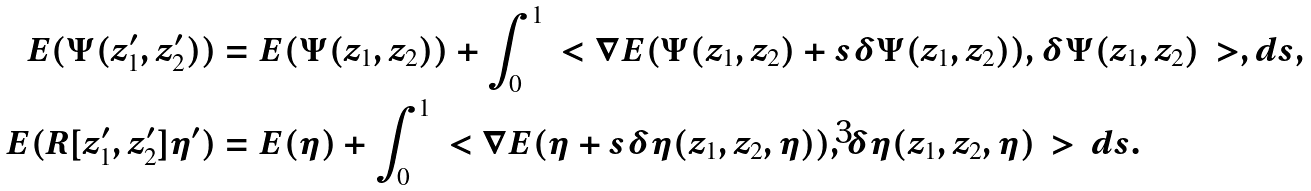<formula> <loc_0><loc_0><loc_500><loc_500>E ( \Psi ( z _ { 1 } ^ { \prime } , z _ { 2 } ^ { \prime } ) ) & = E ( \Psi ( z _ { 1 } , z _ { 2 } ) ) + \int _ { 0 } ^ { 1 } \ < \nabla E ( \Psi ( z _ { 1 } , z _ { 2 } ) + s \delta \Psi ( z _ { 1 } , z _ { 2 } ) ) , \delta \Psi ( z _ { 1 } , z _ { 2 } ) \ > , d s , \\ E ( R [ z _ { 1 } ^ { \prime } , z _ { 2 } ^ { \prime } ] \eta ^ { \prime } ) & = E ( \eta ) + \int _ { 0 } ^ { 1 } \ < \nabla E ( \eta + s \delta \eta ( z _ { 1 } , z _ { 2 } , \eta ) ) , \delta \eta ( z _ { 1 } , z _ { 2 } , \eta ) \ > \, d s .</formula> 